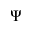Convert formula to latex. <formula><loc_0><loc_0><loc_500><loc_500>\Psi</formula> 